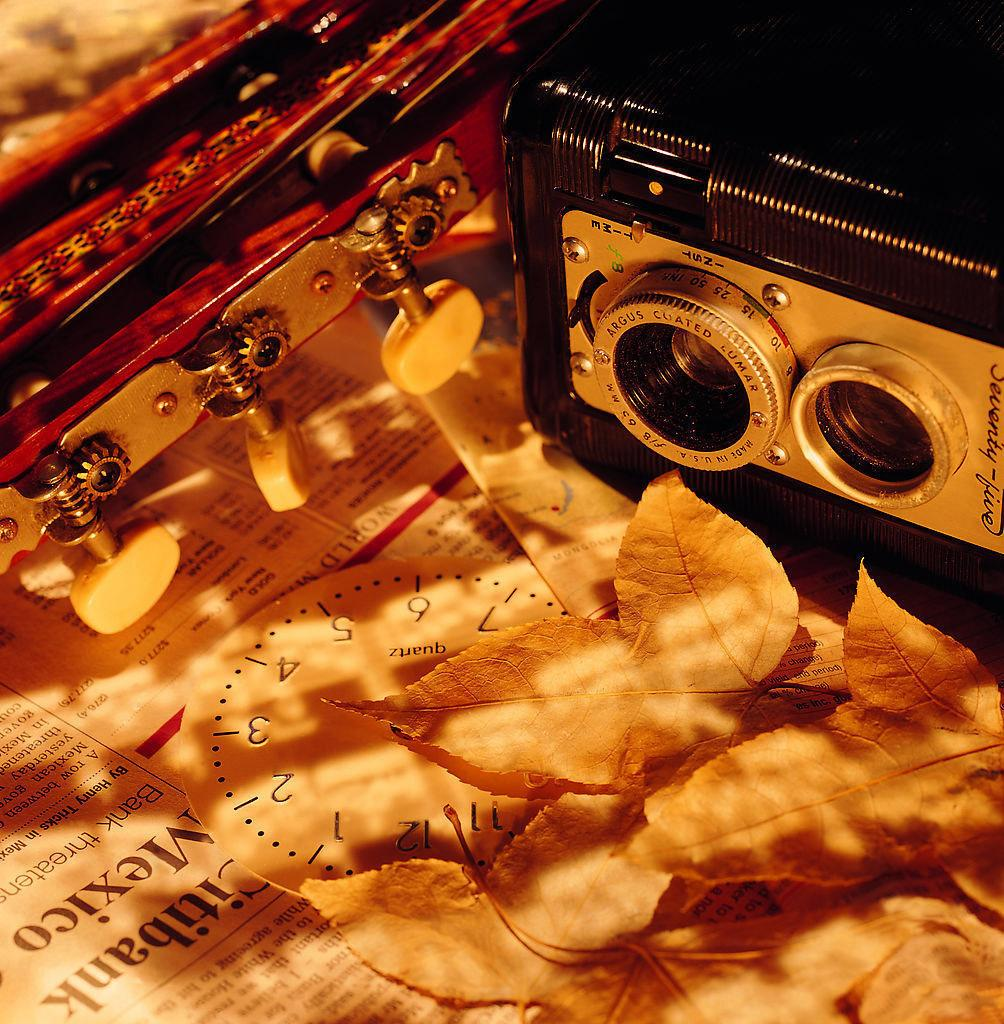What object is located on the right side of the image? There is a radio on the right side of the image. What is at the bottom of the image? There is a newspaper at the bottom of the image. What type of natural elements can be seen in the image? There are leaves in the image. What time-telling device is present in the image? There is a clock in the image. What type of musical instrument is at the top of the image? There is an instrument at the top of the image. How much sugar is present in the image? There is no sugar present in the image. What type of sand can be seen in the image? There is no sand present in the image. 